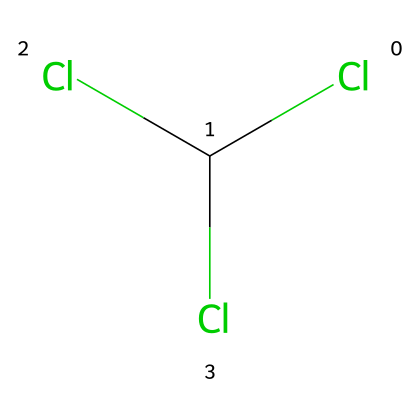What is the name of this chemical? The SMILES representation corresponds to chloroform, which is recognized commonly in both chemical databases and literature as CHCl3.
Answer: chloroform How many chlorine atoms are present in this molecule? The SMILES structure indicates three chlorine atoms (Cl) attached to the carbon atom, which can be counted directly from the representation.
Answer: three What is the molecular formula of this chemical? The molecular composition can be deduced from the SMILES representation, revealing that it consists of one carbon atom and three chlorine atoms, leading to the formula CHCl3.
Answer: CHCl3 What type of chemical is chloroform categorized as? Chloroform is primarily categorized as an organic solvent, especially due to its ability to dissolve a wide range of compounds significantly.
Answer: organic solvent What is one major historical use of chloroform? Chloroform was historically used as an anesthetic in medical procedures, providing a general method to induce unconsciousness prior to modern anesthetics.
Answer: anesthetic How can chloroform be hazardous to humans? The molecule can pose serious health risks, such as respiratory depression and potential toxicity upon exposure, particularly in enclosed spaces or with misuse.
Answer: toxicity Why is chloroform sometimes considered in forensic investigations? Its use in historical crime novels and actual murder cases has led to its association with foul play, making it relevant in forensic investigations for potential use as a poison.
Answer: poison 